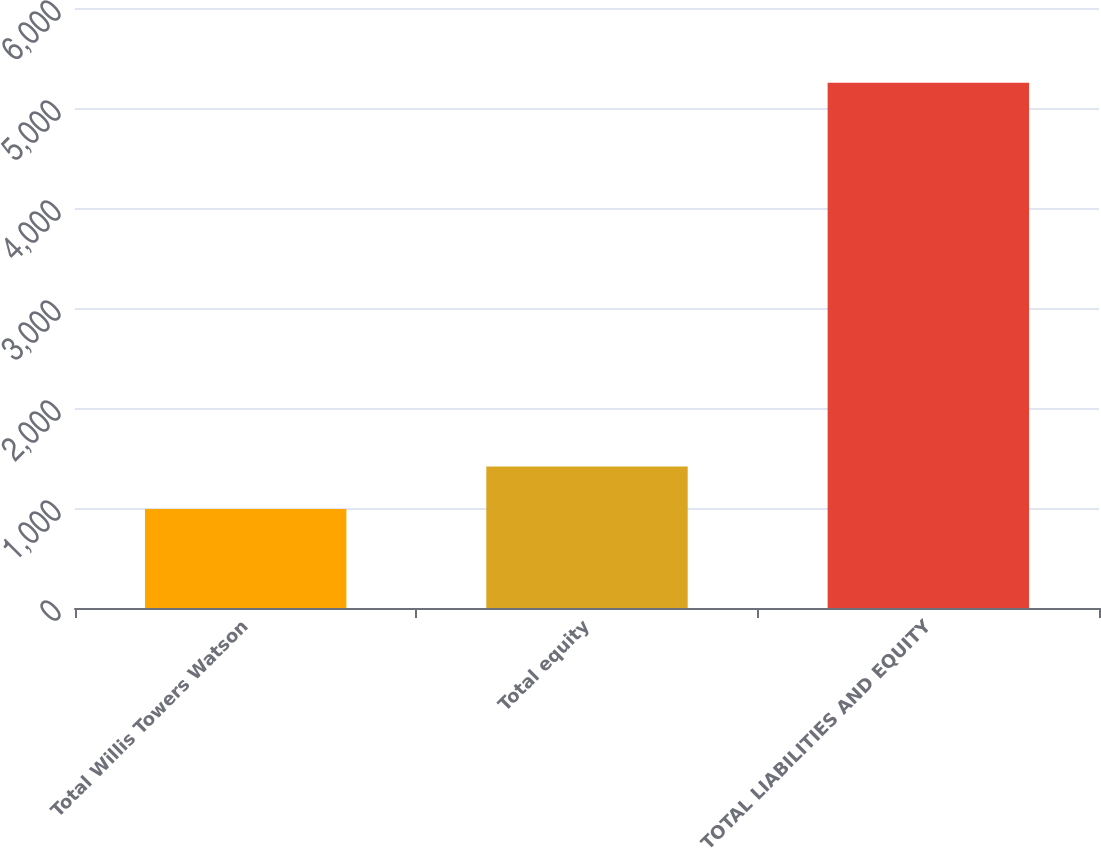Convert chart to OTSL. <chart><loc_0><loc_0><loc_500><loc_500><bar_chart><fcel>Total Willis Towers Watson<fcel>Total equity<fcel>TOTAL LIABILITIES AND EQUITY<nl><fcel>989<fcel>1415.3<fcel>5252<nl></chart> 